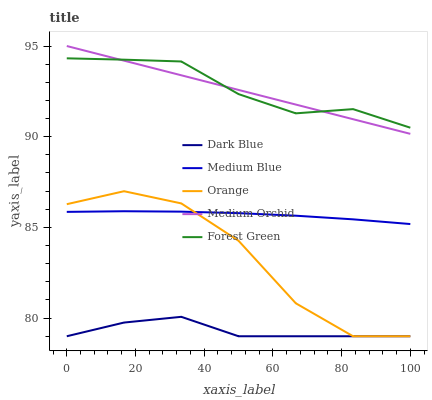Does Dark Blue have the minimum area under the curve?
Answer yes or no. Yes. Does Forest Green have the maximum area under the curve?
Answer yes or no. Yes. Does Forest Green have the minimum area under the curve?
Answer yes or no. No. Does Dark Blue have the maximum area under the curve?
Answer yes or no. No. Is Medium Orchid the smoothest?
Answer yes or no. Yes. Is Orange the roughest?
Answer yes or no. Yes. Is Dark Blue the smoothest?
Answer yes or no. No. Is Dark Blue the roughest?
Answer yes or no. No. Does Orange have the lowest value?
Answer yes or no. Yes. Does Forest Green have the lowest value?
Answer yes or no. No. Does Medium Orchid have the highest value?
Answer yes or no. Yes. Does Forest Green have the highest value?
Answer yes or no. No. Is Dark Blue less than Forest Green?
Answer yes or no. Yes. Is Forest Green greater than Dark Blue?
Answer yes or no. Yes. Does Orange intersect Dark Blue?
Answer yes or no. Yes. Is Orange less than Dark Blue?
Answer yes or no. No. Is Orange greater than Dark Blue?
Answer yes or no. No. Does Dark Blue intersect Forest Green?
Answer yes or no. No. 